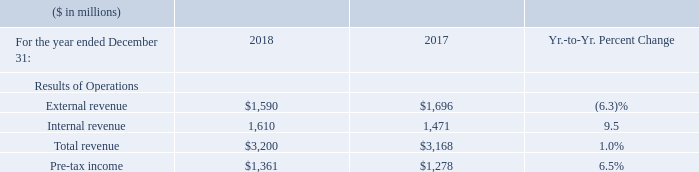The increase in Global Financing total revenue was driven by an increase in internal revenue, partially offset by a decrease in external revenue. Internal revenue grew 9.5 percent driven by increases in internal financing (up 17.6 percent) and internal used equipment sales (up 6.8 percent).
External revenue declined 6.3 percent due to a decrease in external used equipment sales (down 30.8 percent), partially offset by an increase in external financing (up 4.9 percent).
The increase in Global Financing pre-tax income was primarily driven by an increase in gross profit and a decrease in total expense.
What led to increase in Global Financing total revenue? An increase in internal revenue, partially offset by a decrease in external revenue. What led to decline in External revenue  A decrease in external used equipment sales (down 30.8 percent), partially offset by an increase in external financing (up 4.9 percent). What led to increase in Global Financing pre-tax income? An increase in gross profit and a decrease in total expense. What is the increase/ (decrease) in External revenue from 2017 to 2018
Answer scale should be: million. 1,590-1,696
Answer: -106. What is the increase/ (decrease) in Internal Revenue from 2017 to 2018
Answer scale should be: million. 1,610-1,471 
Answer: 139. What is the average of Internal Revenue?
Answer scale should be: million. (1,610+1,471) / 2
Answer: 1540.5. 